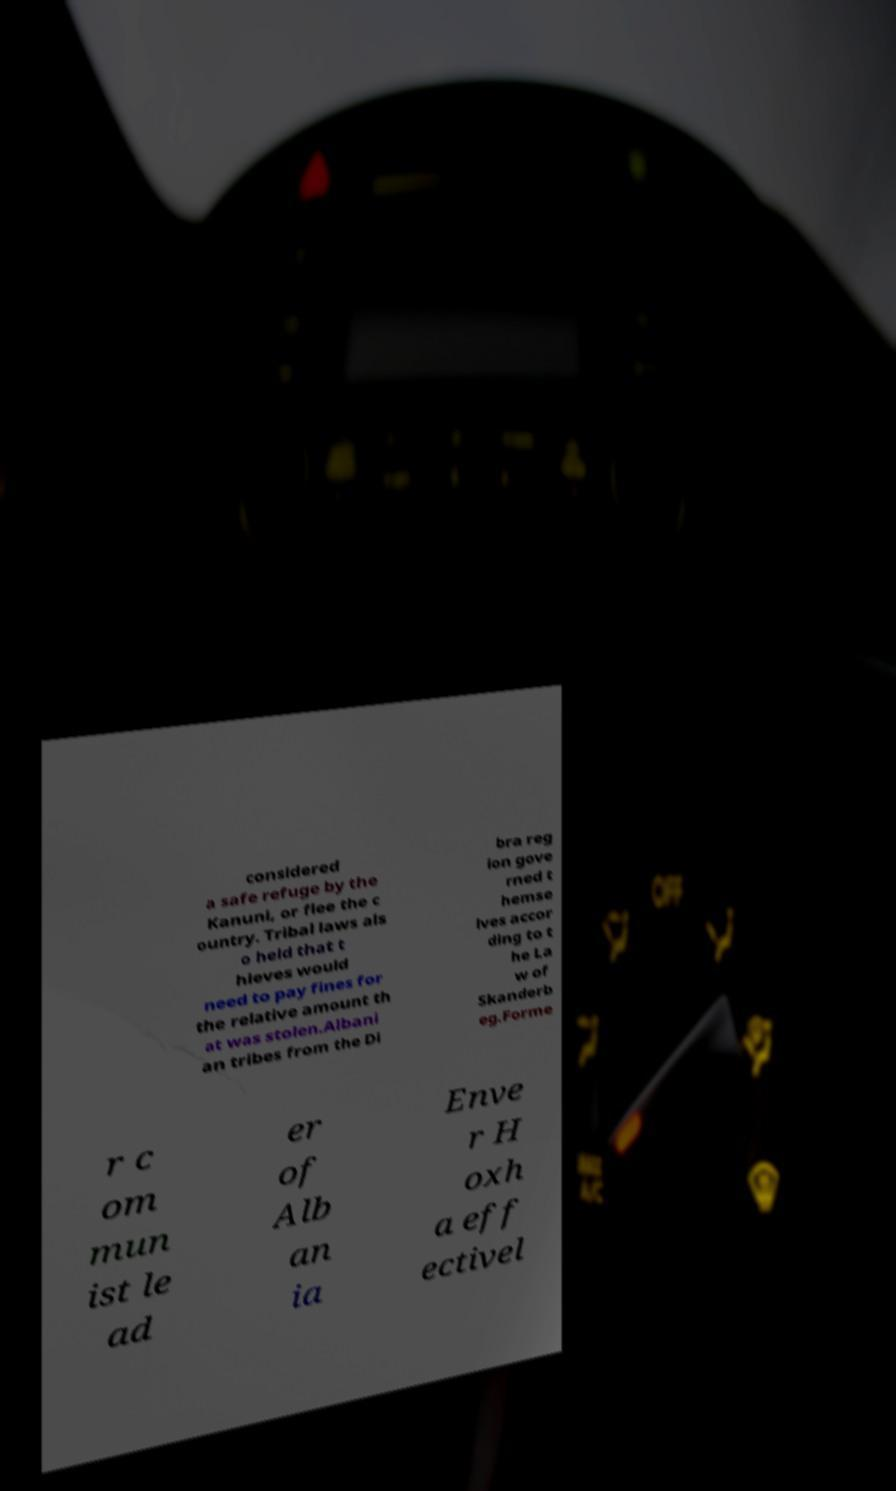Can you accurately transcribe the text from the provided image for me? considered a safe refuge by the Kanuni, or flee the c ountry. Tribal laws als o held that t hieves would need to pay fines for the relative amount th at was stolen.Albani an tribes from the Di bra reg ion gove rned t hemse lves accor ding to t he La w of Skanderb eg.Forme r c om mun ist le ad er of Alb an ia Enve r H oxh a eff ectivel 